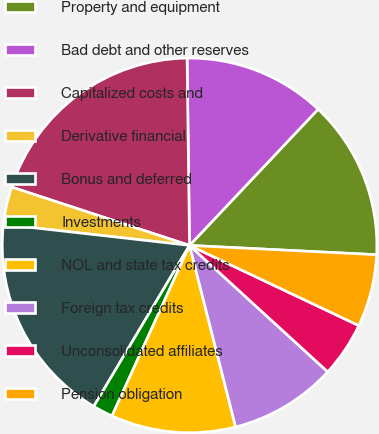<chart> <loc_0><loc_0><loc_500><loc_500><pie_chart><fcel>Property and equipment<fcel>Bad debt and other reserves<fcel>Capitalized costs and<fcel>Derivative financial<fcel>Bonus and deferred<fcel>Investments<fcel>NOL and state tax credits<fcel>Foreign tax credits<fcel>Unconsolidated affiliates<fcel>Pension obligation<nl><fcel>13.75%<fcel>12.25%<fcel>19.75%<fcel>3.25%<fcel>18.25%<fcel>1.75%<fcel>10.75%<fcel>9.25%<fcel>4.75%<fcel>6.25%<nl></chart> 